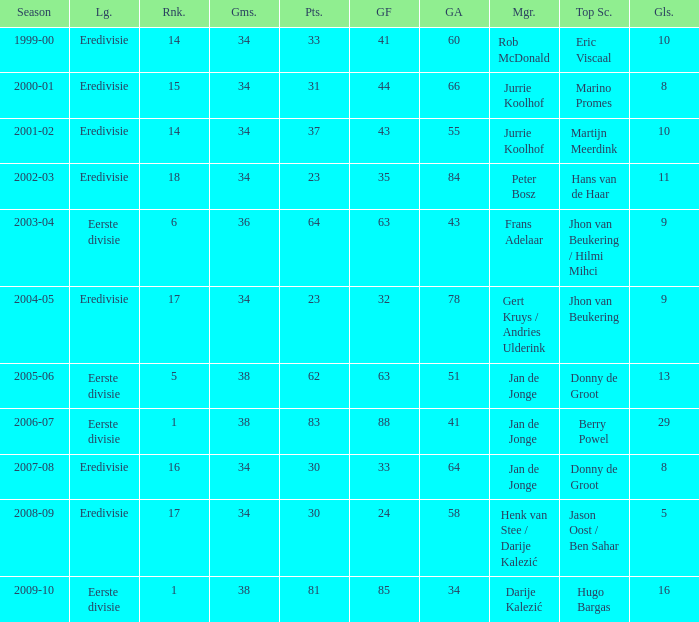How many seasons had a rank of 16? 1.0. 